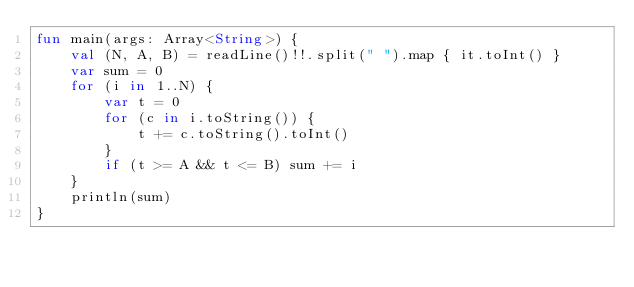Convert code to text. <code><loc_0><loc_0><loc_500><loc_500><_Kotlin_>fun main(args: Array<String>) {
    val (N, A, B) = readLine()!!.split(" ").map { it.toInt() }
    var sum = 0
    for (i in 1..N) {
        var t = 0
        for (c in i.toString()) {
            t += c.toString().toInt()
        }
        if (t >= A && t <= B) sum += i
    }
    println(sum)
}
</code> 